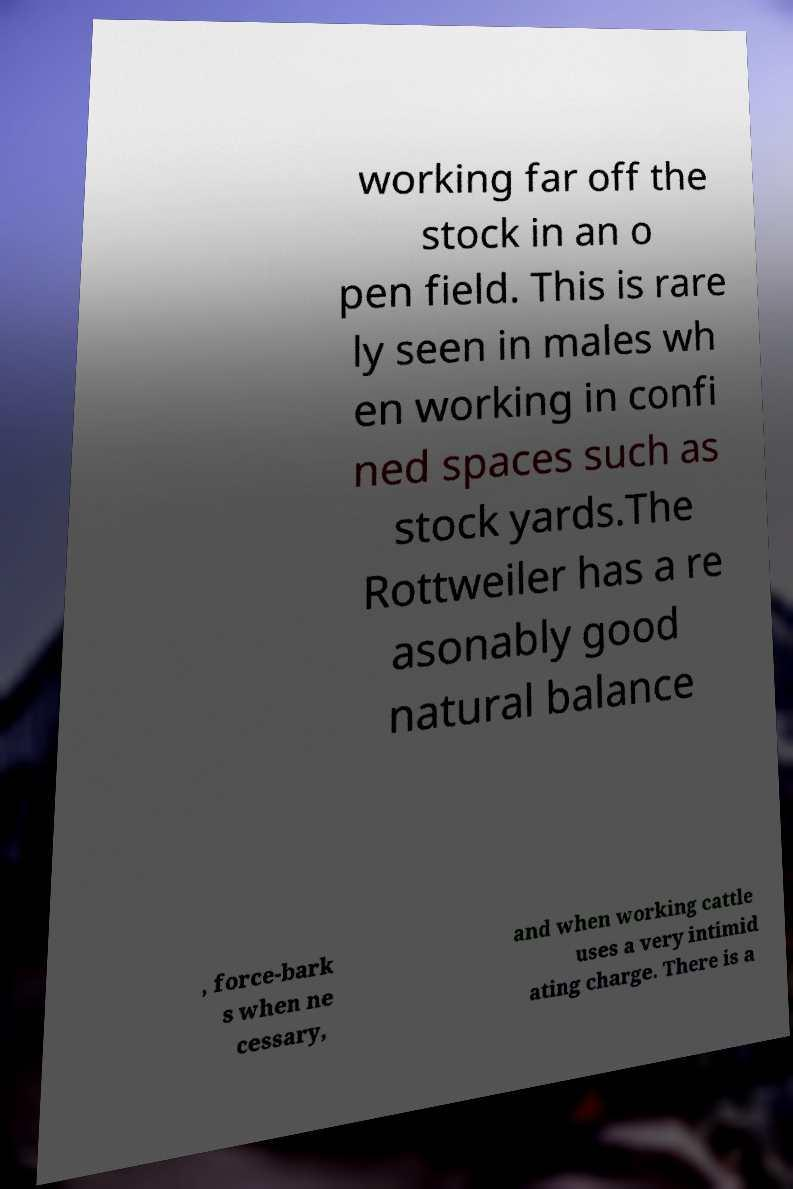Could you assist in decoding the text presented in this image and type it out clearly? working far off the stock in an o pen field. This is rare ly seen in males wh en working in confi ned spaces such as stock yards.The Rottweiler has a re asonably good natural balance , force-bark s when ne cessary, and when working cattle uses a very intimid ating charge. There is a 